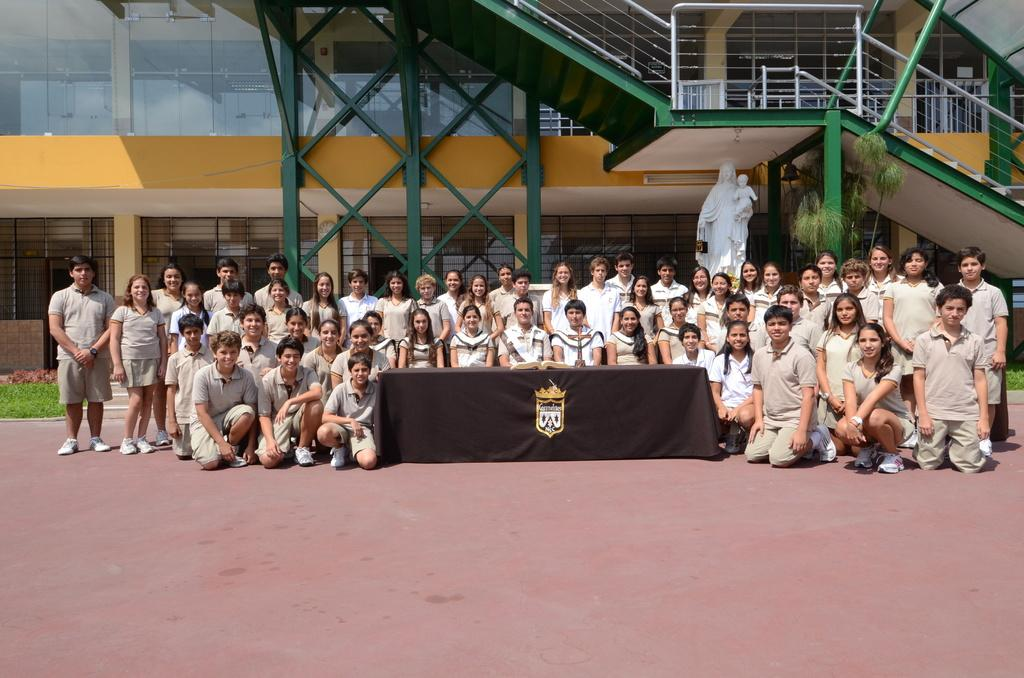How many people are in the image? There is a group of people in the image, but the exact number is not specified. What are the people in the image doing? The people are on the ground, but their specific activity is not mentioned. What can be seen in the background of the image? There is a building and a statue in the background of the image. What type of pickle is the person holding in the image? There is no pickle present in the image. Can you describe the chin of the person in the image? The image does not provide enough detail to describe the chin of any person in the image. 